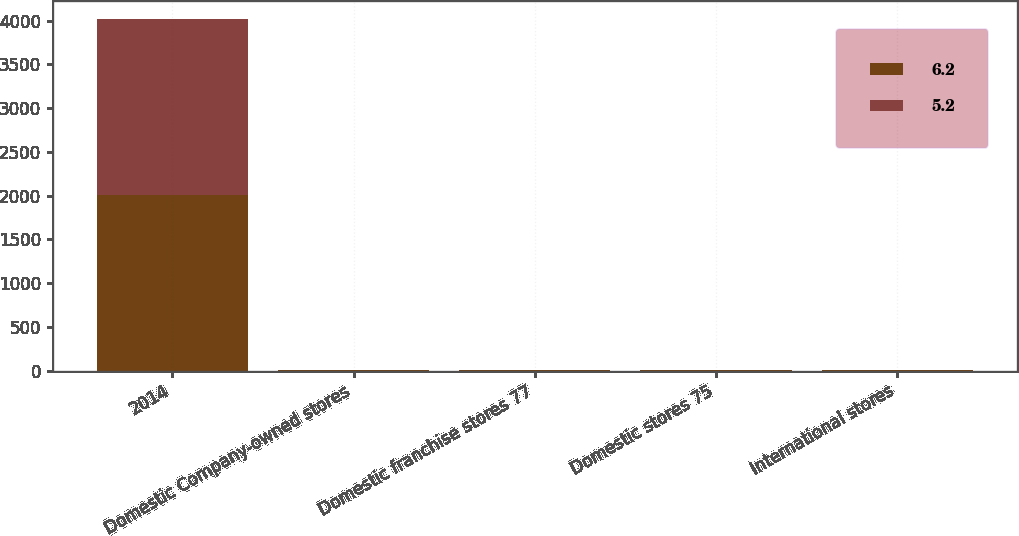Convert chart. <chart><loc_0><loc_0><loc_500><loc_500><stacked_bar_chart><ecel><fcel>2014<fcel>Domestic Company-owned stores<fcel>Domestic franchise stores 77<fcel>Domestic stores 75<fcel>International stores<nl><fcel>6.2<fcel>2013<fcel>3.9<fcel>5.5<fcel>5.4<fcel>6.2<nl><fcel>5.2<fcel>2012<fcel>1.3<fcel>3.2<fcel>3.1<fcel>5.2<nl></chart> 